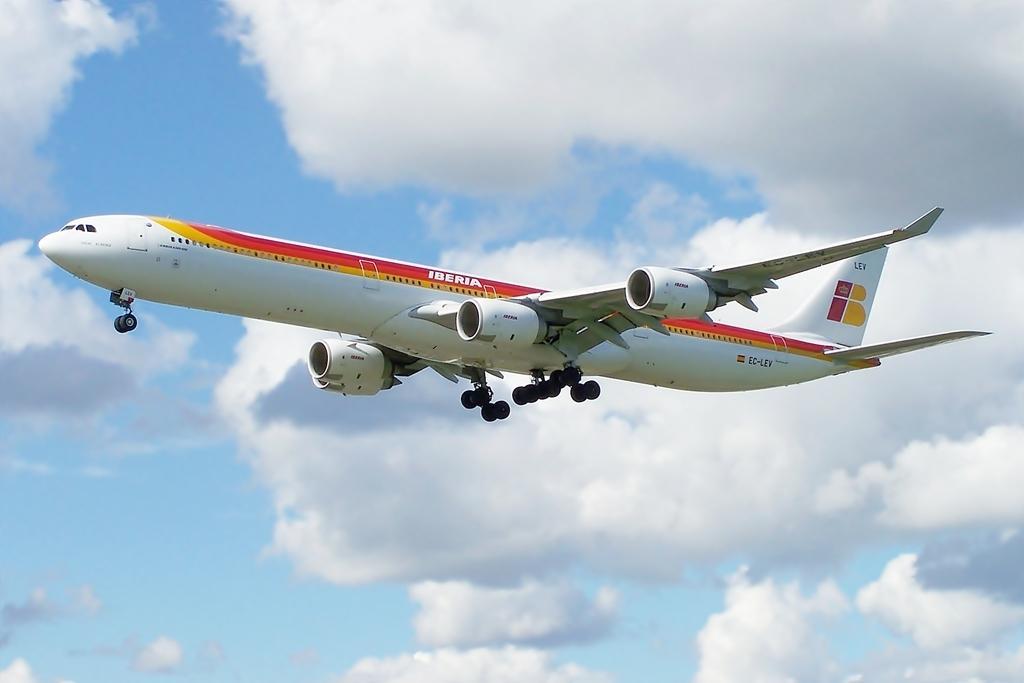Please provide a concise description of this image. There is an airplane in white, red and yellow color combination flying in the air. In the background, there are clouds in the blue sky. 